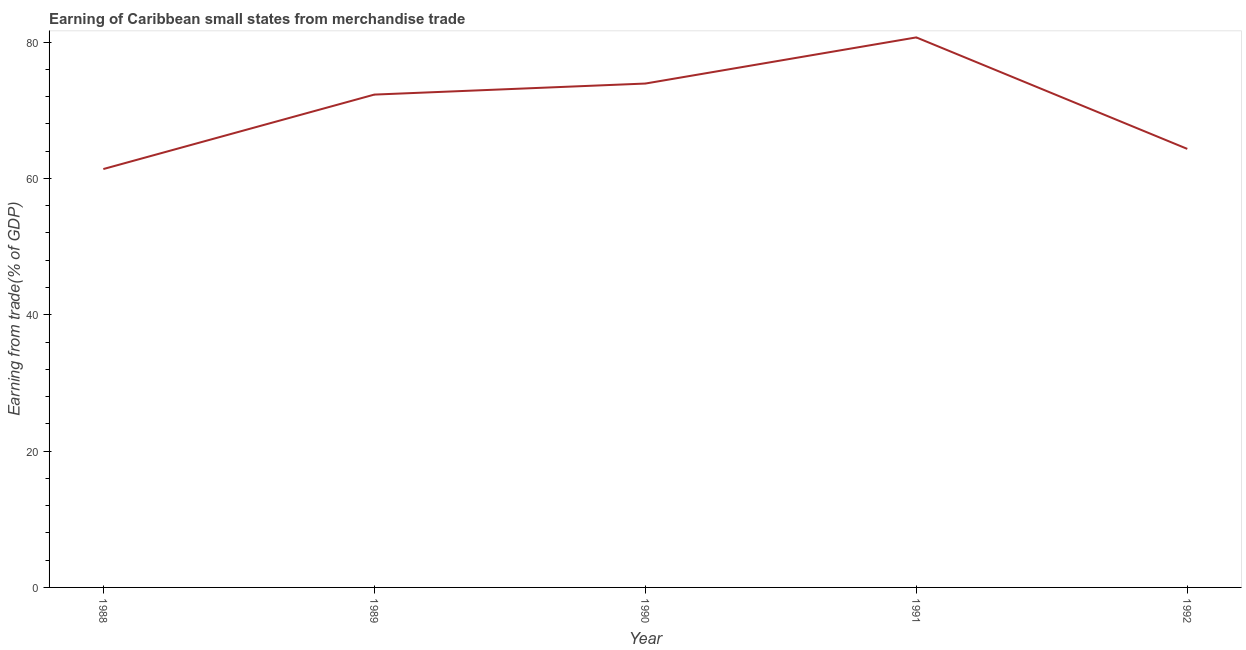What is the earning from merchandise trade in 1992?
Your answer should be very brief. 64.33. Across all years, what is the maximum earning from merchandise trade?
Offer a very short reply. 80.69. Across all years, what is the minimum earning from merchandise trade?
Offer a very short reply. 61.38. In which year was the earning from merchandise trade maximum?
Offer a very short reply. 1991. What is the sum of the earning from merchandise trade?
Give a very brief answer. 352.61. What is the difference between the earning from merchandise trade in 1988 and 1989?
Offer a very short reply. -10.92. What is the average earning from merchandise trade per year?
Offer a terse response. 70.52. What is the median earning from merchandise trade?
Make the answer very short. 72.3. In how many years, is the earning from merchandise trade greater than 52 %?
Your answer should be compact. 5. What is the ratio of the earning from merchandise trade in 1988 to that in 1991?
Your response must be concise. 0.76. Is the earning from merchandise trade in 1988 less than that in 1990?
Ensure brevity in your answer.  Yes. Is the difference between the earning from merchandise trade in 1990 and 1991 greater than the difference between any two years?
Your response must be concise. No. What is the difference between the highest and the second highest earning from merchandise trade?
Ensure brevity in your answer.  6.77. Is the sum of the earning from merchandise trade in 1988 and 1991 greater than the maximum earning from merchandise trade across all years?
Ensure brevity in your answer.  Yes. What is the difference between the highest and the lowest earning from merchandise trade?
Your answer should be compact. 19.31. In how many years, is the earning from merchandise trade greater than the average earning from merchandise trade taken over all years?
Offer a terse response. 3. How many lines are there?
Ensure brevity in your answer.  1. What is the title of the graph?
Your response must be concise. Earning of Caribbean small states from merchandise trade. What is the label or title of the Y-axis?
Your answer should be very brief. Earning from trade(% of GDP). What is the Earning from trade(% of GDP) of 1988?
Your response must be concise. 61.38. What is the Earning from trade(% of GDP) of 1989?
Make the answer very short. 72.3. What is the Earning from trade(% of GDP) in 1990?
Your response must be concise. 73.92. What is the Earning from trade(% of GDP) of 1991?
Give a very brief answer. 80.69. What is the Earning from trade(% of GDP) in 1992?
Provide a short and direct response. 64.33. What is the difference between the Earning from trade(% of GDP) in 1988 and 1989?
Ensure brevity in your answer.  -10.92. What is the difference between the Earning from trade(% of GDP) in 1988 and 1990?
Your answer should be compact. -12.54. What is the difference between the Earning from trade(% of GDP) in 1988 and 1991?
Offer a terse response. -19.31. What is the difference between the Earning from trade(% of GDP) in 1988 and 1992?
Make the answer very short. -2.96. What is the difference between the Earning from trade(% of GDP) in 1989 and 1990?
Offer a terse response. -1.62. What is the difference between the Earning from trade(% of GDP) in 1989 and 1991?
Provide a succinct answer. -8.39. What is the difference between the Earning from trade(% of GDP) in 1989 and 1992?
Give a very brief answer. 7.97. What is the difference between the Earning from trade(% of GDP) in 1990 and 1991?
Your answer should be compact. -6.77. What is the difference between the Earning from trade(% of GDP) in 1990 and 1992?
Ensure brevity in your answer.  9.58. What is the difference between the Earning from trade(% of GDP) in 1991 and 1992?
Ensure brevity in your answer.  16.35. What is the ratio of the Earning from trade(% of GDP) in 1988 to that in 1989?
Keep it short and to the point. 0.85. What is the ratio of the Earning from trade(% of GDP) in 1988 to that in 1990?
Provide a short and direct response. 0.83. What is the ratio of the Earning from trade(% of GDP) in 1988 to that in 1991?
Provide a short and direct response. 0.76. What is the ratio of the Earning from trade(% of GDP) in 1988 to that in 1992?
Offer a terse response. 0.95. What is the ratio of the Earning from trade(% of GDP) in 1989 to that in 1991?
Offer a terse response. 0.9. What is the ratio of the Earning from trade(% of GDP) in 1989 to that in 1992?
Your response must be concise. 1.12. What is the ratio of the Earning from trade(% of GDP) in 1990 to that in 1991?
Offer a very short reply. 0.92. What is the ratio of the Earning from trade(% of GDP) in 1990 to that in 1992?
Provide a succinct answer. 1.15. What is the ratio of the Earning from trade(% of GDP) in 1991 to that in 1992?
Keep it short and to the point. 1.25. 